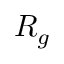Convert formula to latex. <formula><loc_0><loc_0><loc_500><loc_500>R _ { g }</formula> 